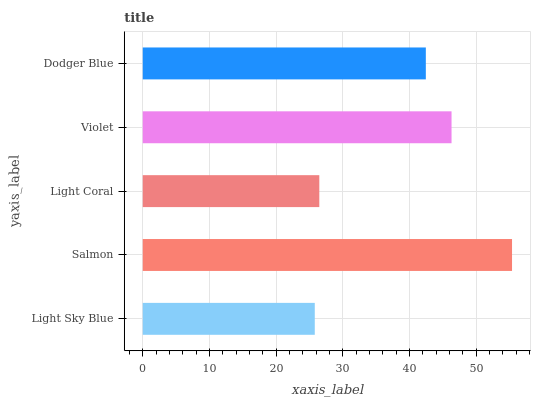Is Light Sky Blue the minimum?
Answer yes or no. Yes. Is Salmon the maximum?
Answer yes or no. Yes. Is Light Coral the minimum?
Answer yes or no. No. Is Light Coral the maximum?
Answer yes or no. No. Is Salmon greater than Light Coral?
Answer yes or no. Yes. Is Light Coral less than Salmon?
Answer yes or no. Yes. Is Light Coral greater than Salmon?
Answer yes or no. No. Is Salmon less than Light Coral?
Answer yes or no. No. Is Dodger Blue the high median?
Answer yes or no. Yes. Is Dodger Blue the low median?
Answer yes or no. Yes. Is Salmon the high median?
Answer yes or no. No. Is Light Coral the low median?
Answer yes or no. No. 